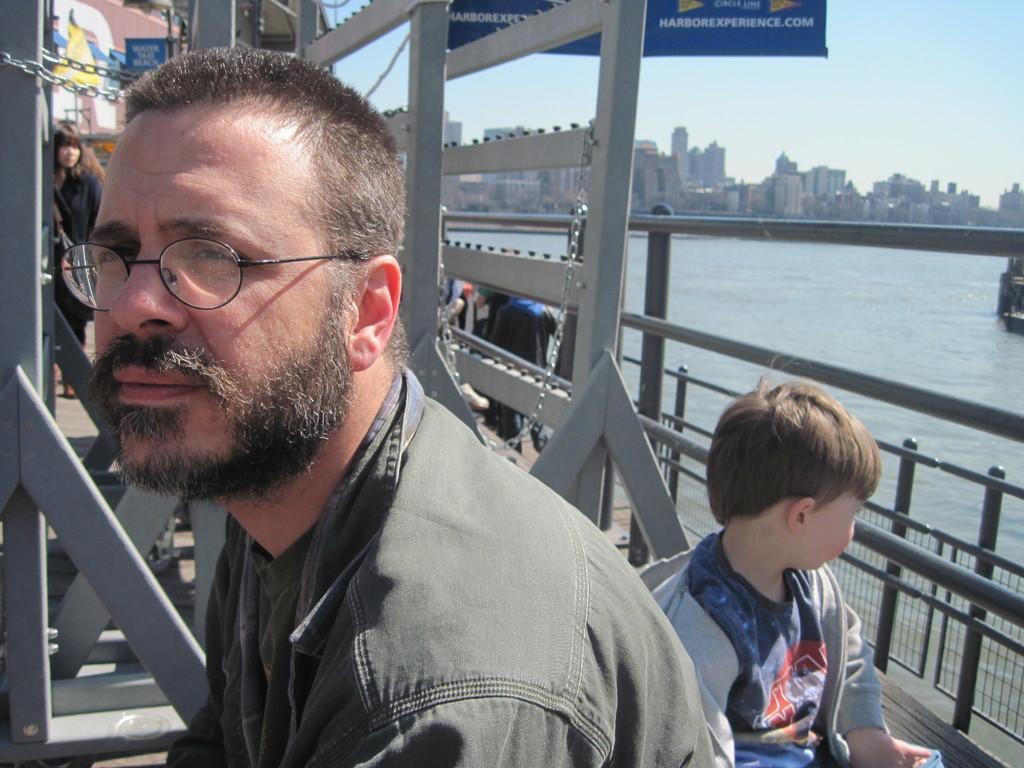In one or two sentences, can you explain what this image depicts? In the image there is a man in grey shirt and spects sitting in the front and behind there is a boy sitting, it seems to be clicked on a bridge, in the back there are few persons visible, on the right side there is a lake and in the background there are buildings and above its sky. 